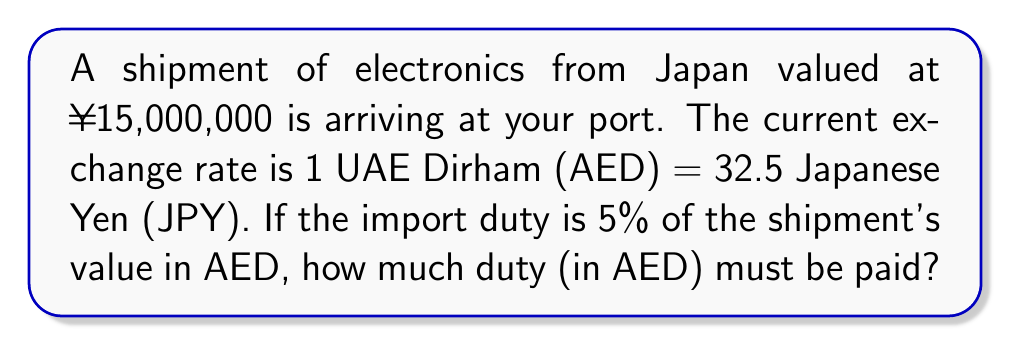Provide a solution to this math problem. To solve this problem, we'll follow these steps:

1. Convert the shipment value from JPY to AED:
   $$\text{AED value} = \frac{\text{JPY value}}{\text{Exchange rate}}$$
   $$\text{AED value} = \frac{15,000,000}{32.5} = 461,538.46 \text{ AED}$$

2. Calculate the import duty:
   $$\text{Duty} = \text{AED value} \times \text{Duty rate}$$
   $$\text{Duty} = 461,538.46 \times 0.05 = 23,076.92 \text{ AED}$$

3. Round the result to two decimal places:
   $$\text{Duty} = 23,076.92 \text{ AED}$$
Answer: 23,076.92 AED 